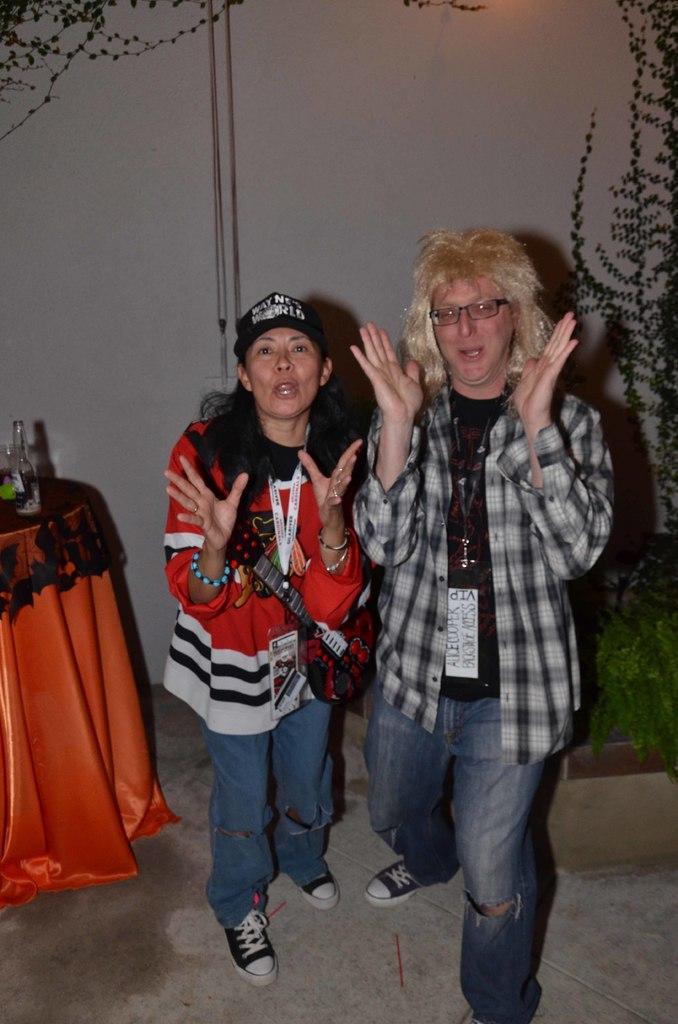Please provide a concise description of this image. In this image I can see two people with different color dresses. I can see one person is wearing the cap. To the left there is a bottle on the black and orange color cloth. To the right there is a plant. In the background I can see the wall. 